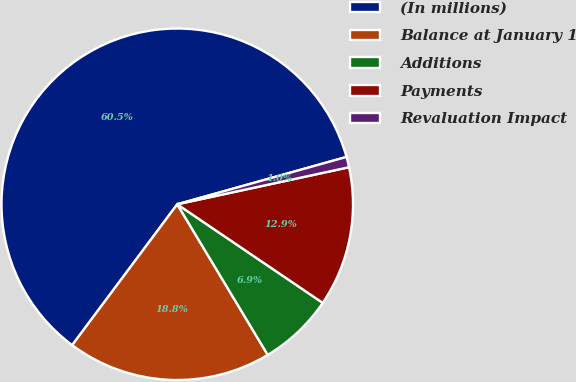<chart> <loc_0><loc_0><loc_500><loc_500><pie_chart><fcel>(In millions)<fcel>Balance at January 1<fcel>Additions<fcel>Payments<fcel>Revaluation Impact<nl><fcel>60.46%<fcel>18.81%<fcel>6.91%<fcel>12.86%<fcel>0.96%<nl></chart> 